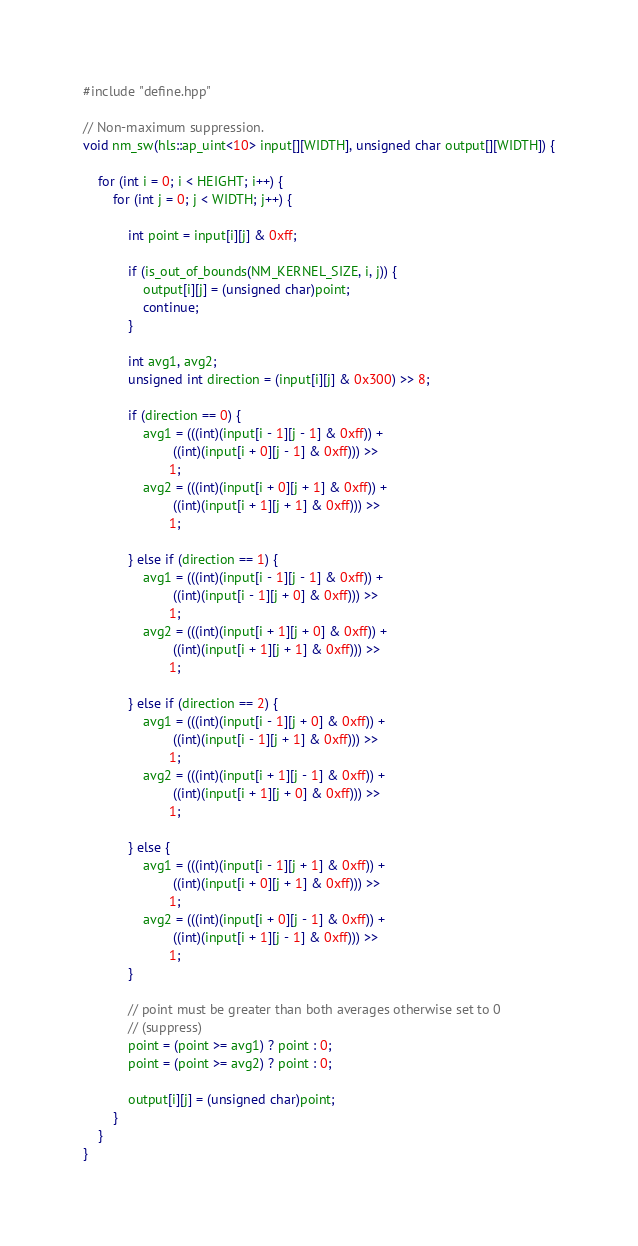Convert code to text. <code><loc_0><loc_0><loc_500><loc_500><_C++_>#include "define.hpp"

// Non-maximum suppression.
void nm_sw(hls::ap_uint<10> input[][WIDTH], unsigned char output[][WIDTH]) {

    for (int i = 0; i < HEIGHT; i++) {
        for (int j = 0; j < WIDTH; j++) {

            int point = input[i][j] & 0xff;

            if (is_out_of_bounds(NM_KERNEL_SIZE, i, j)) {
                output[i][j] = (unsigned char)point;
                continue;
            }

            int avg1, avg2;
            unsigned int direction = (input[i][j] & 0x300) >> 8;

            if (direction == 0) {
                avg1 = (((int)(input[i - 1][j - 1] & 0xff)) +
                        ((int)(input[i + 0][j - 1] & 0xff))) >>
                       1;
                avg2 = (((int)(input[i + 0][j + 1] & 0xff)) +
                        ((int)(input[i + 1][j + 1] & 0xff))) >>
                       1;

            } else if (direction == 1) {
                avg1 = (((int)(input[i - 1][j - 1] & 0xff)) +
                        ((int)(input[i - 1][j + 0] & 0xff))) >>
                       1;
                avg2 = (((int)(input[i + 1][j + 0] & 0xff)) +
                        ((int)(input[i + 1][j + 1] & 0xff))) >>
                       1;

            } else if (direction == 2) {
                avg1 = (((int)(input[i - 1][j + 0] & 0xff)) +
                        ((int)(input[i - 1][j + 1] & 0xff))) >>
                       1;
                avg2 = (((int)(input[i + 1][j - 1] & 0xff)) +
                        ((int)(input[i + 1][j + 0] & 0xff))) >>
                       1;

            } else {
                avg1 = (((int)(input[i - 1][j + 1] & 0xff)) +
                        ((int)(input[i + 0][j + 1] & 0xff))) >>
                       1;
                avg2 = (((int)(input[i + 0][j - 1] & 0xff)) +
                        ((int)(input[i + 1][j - 1] & 0xff))) >>
                       1;
            }

            // point must be greater than both averages otherwise set to 0
            // (suppress)
            point = (point >= avg1) ? point : 0;
            point = (point >= avg2) ? point : 0;

            output[i][j] = (unsigned char)point;
        }
    }
}
</code> 